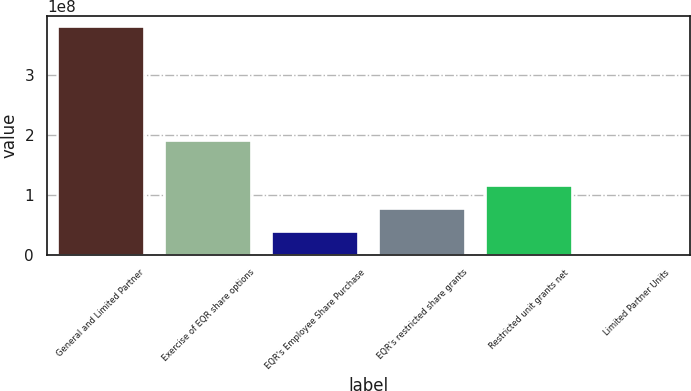<chart> <loc_0><loc_0><loc_500><loc_500><bar_chart><fcel>General and Limited Partner<fcel>Exercise of EQR share options<fcel>EQR's Employee Share Purchase<fcel>EQR's restricted share grants<fcel>Restricted unit grants net<fcel>Limited Partner Units<nl><fcel>3.79183e+08<fcel>1.89591e+08<fcel>3.79183e+07<fcel>7.58365e+07<fcel>1.13755e+08<fcel>3.8<nl></chart> 